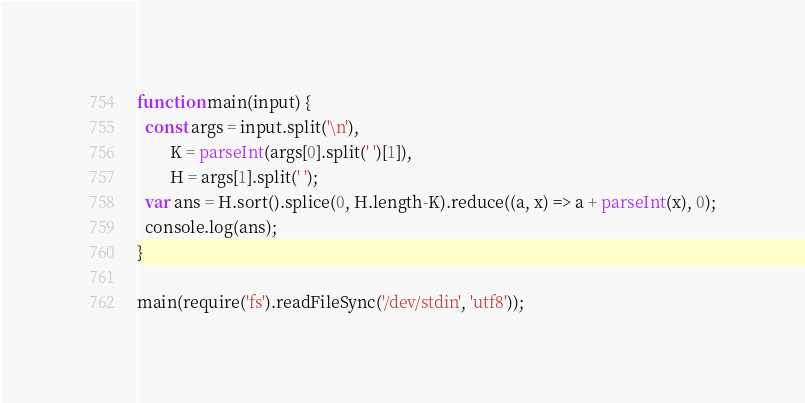<code> <loc_0><loc_0><loc_500><loc_500><_JavaScript_>function main(input) {
  const args = input.split('\n'),
        K = parseInt(args[0].split(' ')[1]),
        H = args[1].split(' ');
  var ans = H.sort().splice(0, H.length-K).reduce((a, x) => a + parseInt(x), 0);
  console.log(ans);
}

main(require('fs').readFileSync('/dev/stdin', 'utf8'));</code> 